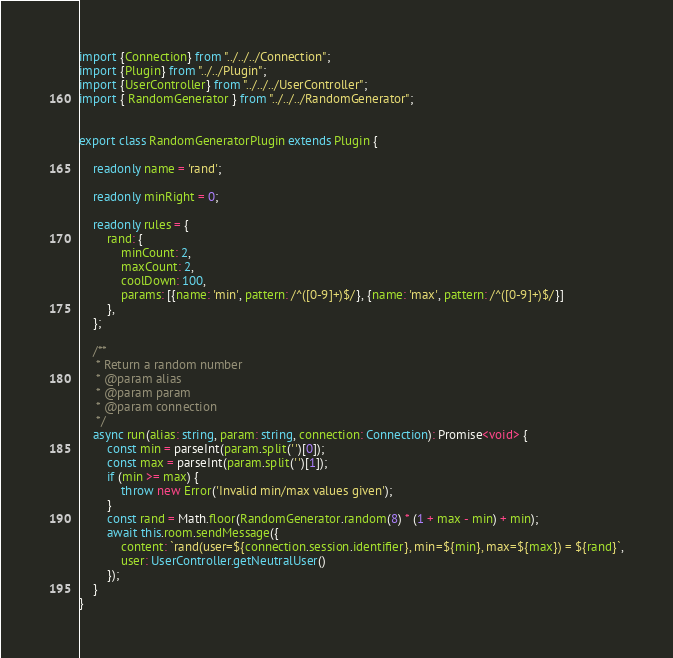<code> <loc_0><loc_0><loc_500><loc_500><_TypeScript_>import {Connection} from "../../../Connection";
import {Plugin} from "../../Plugin";
import {UserController} from "../../../UserController";
import { RandomGenerator } from "../../../RandomGenerator";


export class RandomGeneratorPlugin extends Plugin {

    readonly name = 'rand';

    readonly minRight = 0;

    readonly rules = {
        rand: {
            minCount: 2,
            maxCount: 2,
            coolDown: 100,
            params: [{name: 'min', pattern: /^([0-9]+)$/}, {name: 'max', pattern: /^([0-9]+)$/}]
        },
    };

    /**
     * Return a random number
     * @param alias
     * @param param
     * @param connection
     */
    async run(alias: string, param: string, connection: Connection): Promise<void> {
        const min = parseInt(param.split(' ')[0]);
        const max = parseInt(param.split(' ')[1]);
        if (min >= max) {
            throw new Error('Invalid min/max values given');
        }
        const rand = Math.floor(RandomGenerator.random(8) * (1 + max - min) + min);
        await this.room.sendMessage({
            content: `rand(user=${connection.session.identifier}, min=${min}, max=${max}) = ${rand}`,
            user: UserController.getNeutralUser()
        });
    }
}
</code> 